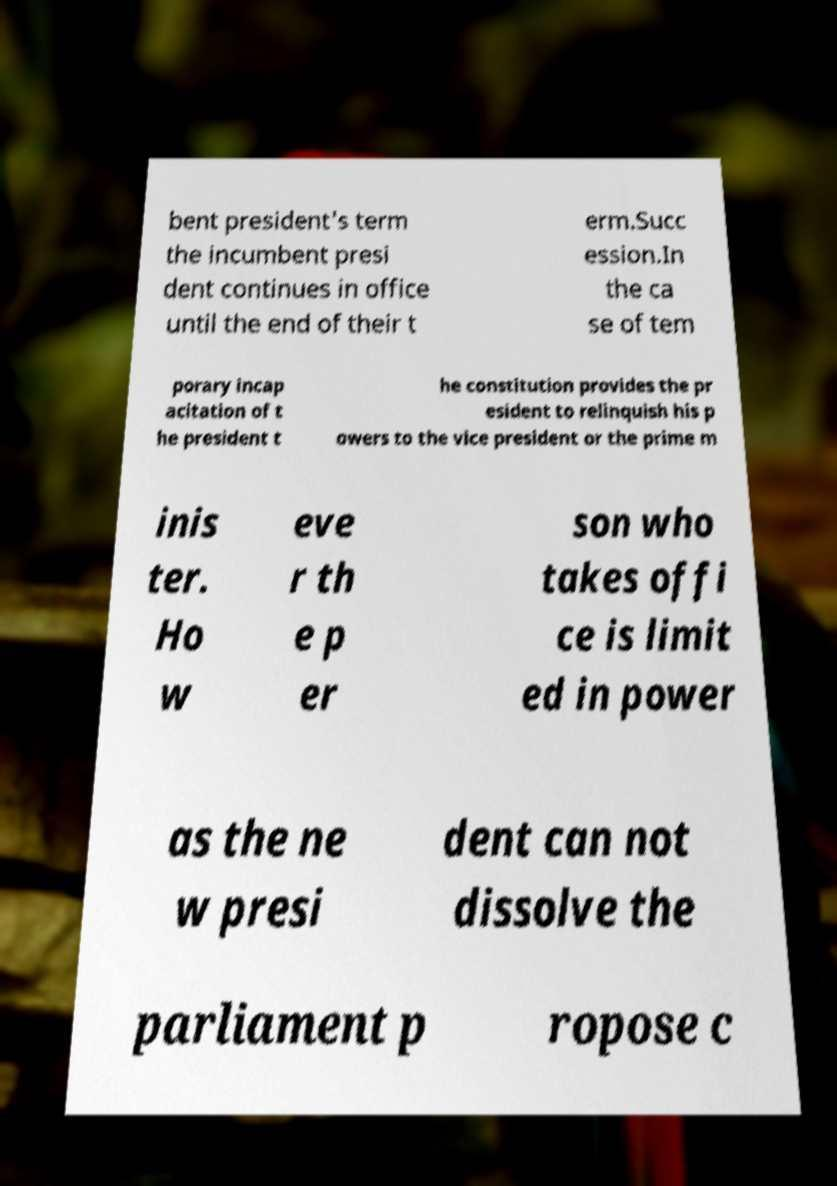I need the written content from this picture converted into text. Can you do that? bent president's term the incumbent presi dent continues in office until the end of their t erm.Succ ession.In the ca se of tem porary incap acitation of t he president t he constitution provides the pr esident to relinquish his p owers to the vice president or the prime m inis ter. Ho w eve r th e p er son who takes offi ce is limit ed in power as the ne w presi dent can not dissolve the parliament p ropose c 